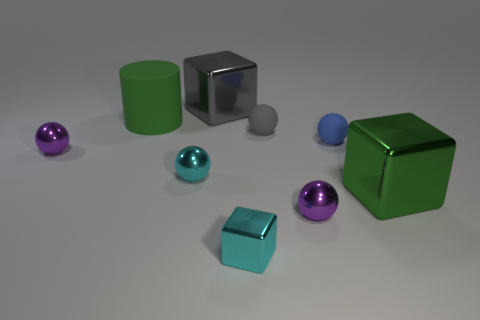Subtract all gray matte spheres. How many spheres are left? 4 Subtract all gray balls. How many balls are left? 4 Subtract all blue cylinders. Subtract all brown cubes. How many cylinders are left? 1 Add 1 red rubber cylinders. How many objects exist? 10 Subtract all blocks. How many objects are left? 6 Subtract 0 yellow cylinders. How many objects are left? 9 Subtract all green things. Subtract all small objects. How many objects are left? 1 Add 5 purple spheres. How many purple spheres are left? 7 Add 5 tiny red things. How many tiny red things exist? 5 